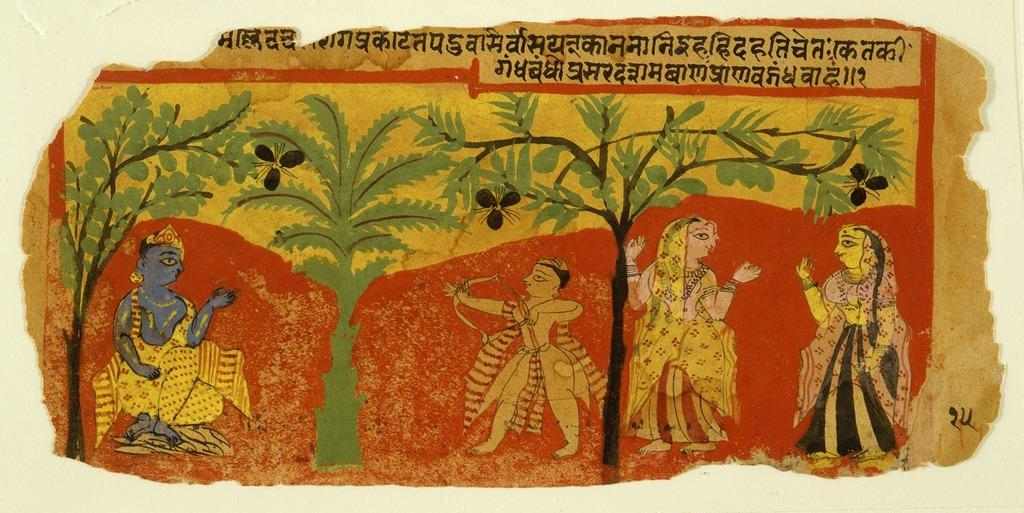What is on the wall in the image? There is a poster on the wall in the image. What is depicted on the poster? The poster contains people, trees, letters, and numbers. Can you describe the content of the poster in more detail? The poster features people interacting with trees, and there are also letters and numbers present. What type of person is eating a meal in the image? There is no person eating a meal in the image; the image only contains a poster with people, trees, letters, and numbers. 